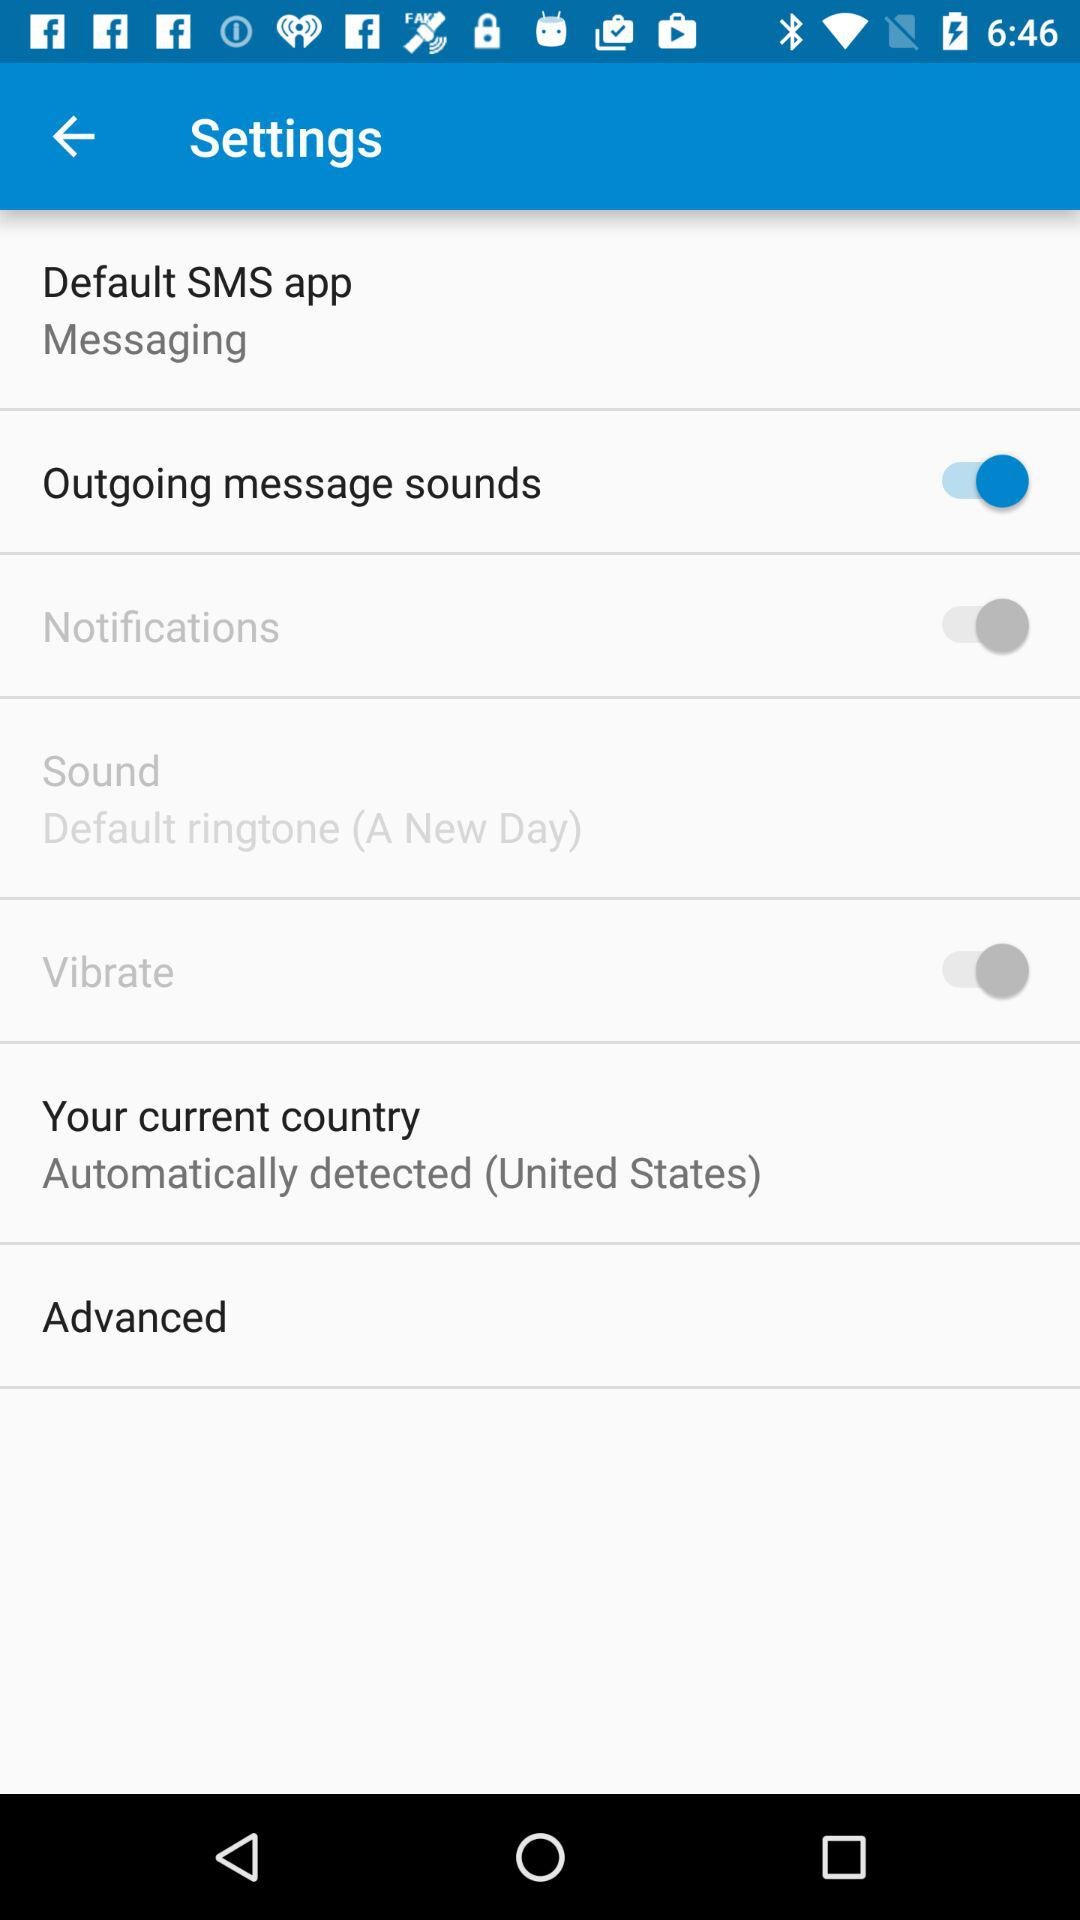What is the current country? The current country is the United States. 